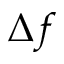<formula> <loc_0><loc_0><loc_500><loc_500>\Delta f</formula> 